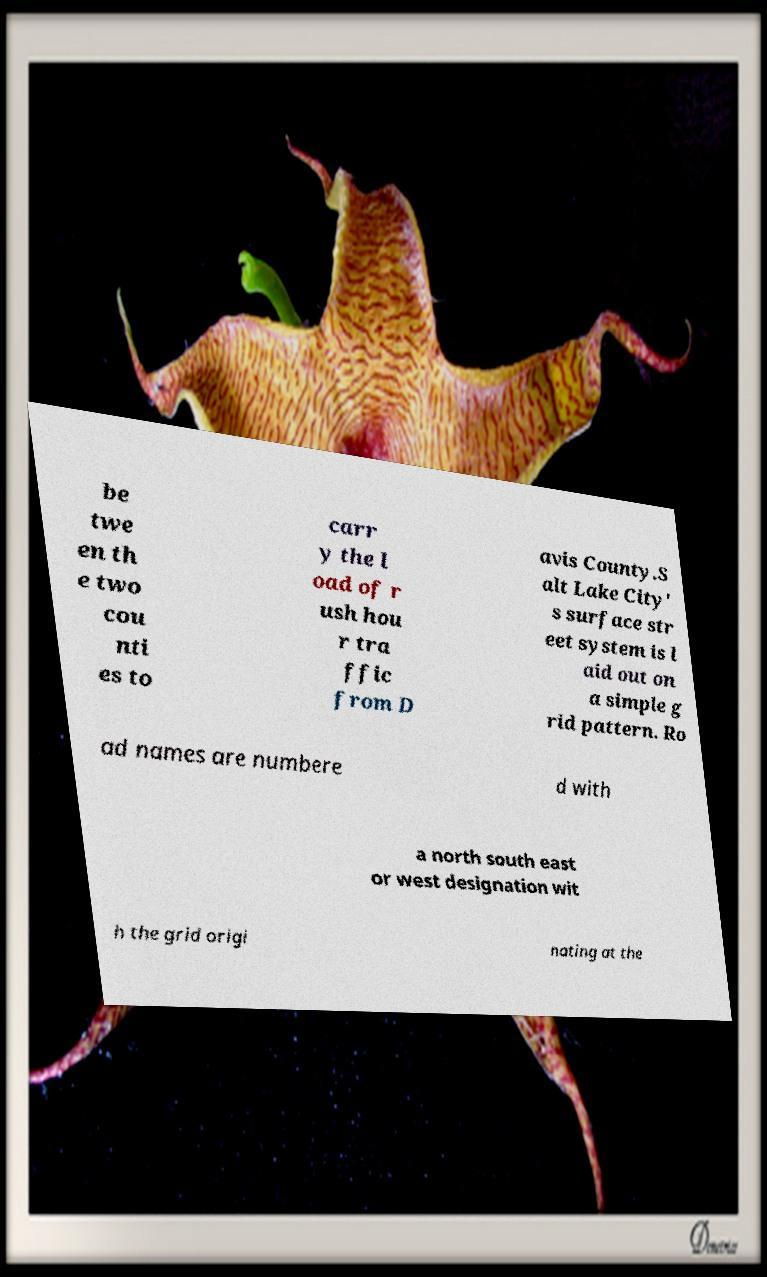What messages or text are displayed in this image? I need them in a readable, typed format. be twe en th e two cou nti es to carr y the l oad of r ush hou r tra ffic from D avis County.S alt Lake City' s surface str eet system is l aid out on a simple g rid pattern. Ro ad names are numbere d with a north south east or west designation wit h the grid origi nating at the 